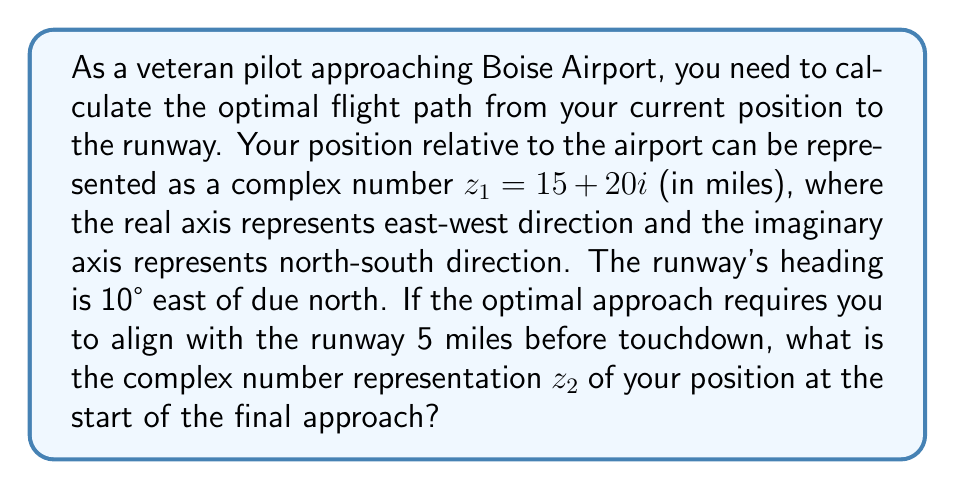Can you answer this question? To solve this problem, we'll follow these steps:

1) First, we need to represent the runway's direction as a complex number. The runway is 10° east of due north, so we can represent it as:

   $$e^{i\theta} = \cos\theta + i\sin\theta = \cos(10°) + i\sin(10°)$$

2) We want to be 5 miles away from the airport on this line. So, we multiply this unit vector by 5:

   $$5(\cos(10°) + i\sin(10°)) = 5\cos(10°) + 5i\sin(10°)$$

3) Now, we need to subtract this vector from our current position to find the position at the start of the final approach:

   $$z_2 = z_1 - 5(\cos(10°) + i\sin(10°))$$
   $$z_2 = (15 + 20i) - (5\cos(10°) + 5i\sin(10°))$$

4) Let's calculate the values:
   
   $\cos(10°) \approx 0.9848$
   $\sin(10°) \approx 0.1736$

5) Substituting these values:

   $$z_2 = (15 + 20i) - (4.9240 + 0.8680i)$$
   $$z_2 = (15 - 4.9240) + (20 - 0.8680)i$$
   $$z_2 = 10.0760 + 19.1320i$$

6) Rounding to two decimal places:

   $$z_2 \approx 10.08 + 19.13i$$

This complex number represents the optimal position to begin the final approach, in miles relative to the airport.
Answer: $z_2 \approx 10.08 + 19.13i$ miles 